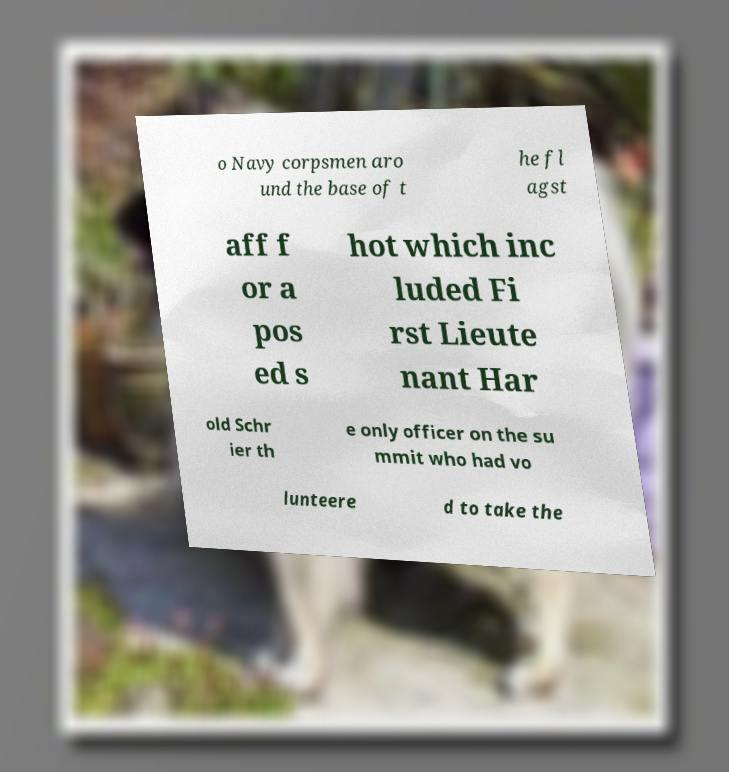Could you assist in decoding the text presented in this image and type it out clearly? o Navy corpsmen aro und the base of t he fl agst aff f or a pos ed s hot which inc luded Fi rst Lieute nant Har old Schr ier th e only officer on the su mmit who had vo lunteere d to take the 